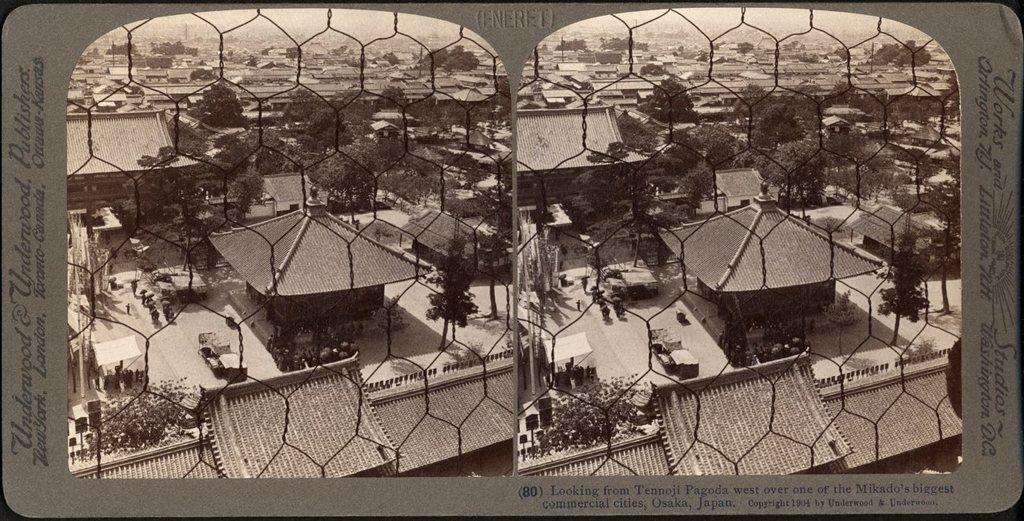What is the main subject of the image? The image is an edited representation of a city. What structures can be seen in the image? There are buildings in the image. What other objects are present in the image? There are poles, boards, and trees in the image. What part of the natural environment is visible in the image? The sky is visible in the image. How many cacti can be seen in the image? There are no cacti present in the image. What type of mass is being used to hold the buildings together in the image? The image is an edited representation, and there is no information about the materials used to construct the buildings. 